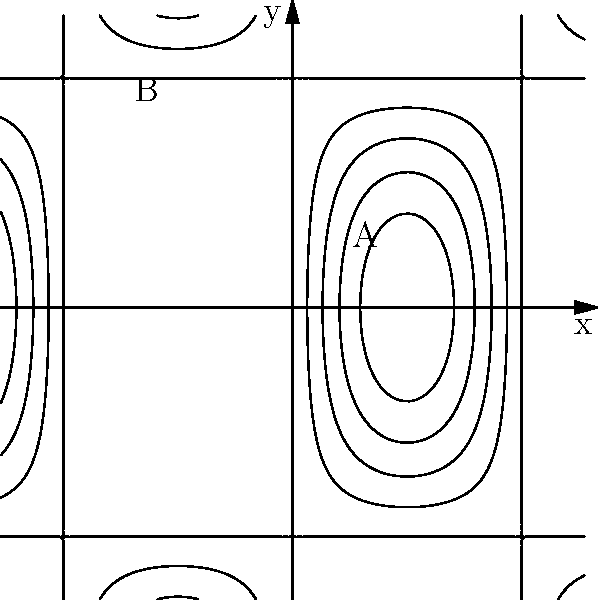As a film director scouting locations, you come across this topographic map for a potential shooting site. Which point, A or B, would provide a more dramatic elevation for a pivotal scene, and why might this choice impact your cinematic vision? To answer this question, we need to interpret the topographic contour lines:

1. Contour lines represent points of equal elevation on a map.
2. Closer lines indicate steeper terrain, while wider spacing suggests gentler slopes.
3. Examining point A:
   - It's located in an area with wider spaced contour lines.
   - This indicates a gentler slope and lower elevation change.
4. Examining point B:
   - It's situated where contour lines are closer together.
   - This suggests a steeper slope and more significant elevation change.
5. Cinematic consideration:
   - Point B offers more dramatic elevation due to its steeper terrain.
   - This location could provide more dynamic camera angles and visually striking compositions.
   - The heightened elevation might symbolize the climax or tension in a scene.
6. Impact on cinematic vision:
   - Choosing point B aligns with creating visual metaphors for conflict or character growth.
   - The steeper terrain could reflect the challenges faced by characters.
   - It offers more opportunities for creative shot composition and camera movement.
Answer: Point B, offering steeper terrain for dramatic visual metaphors and dynamic shot compositions. 